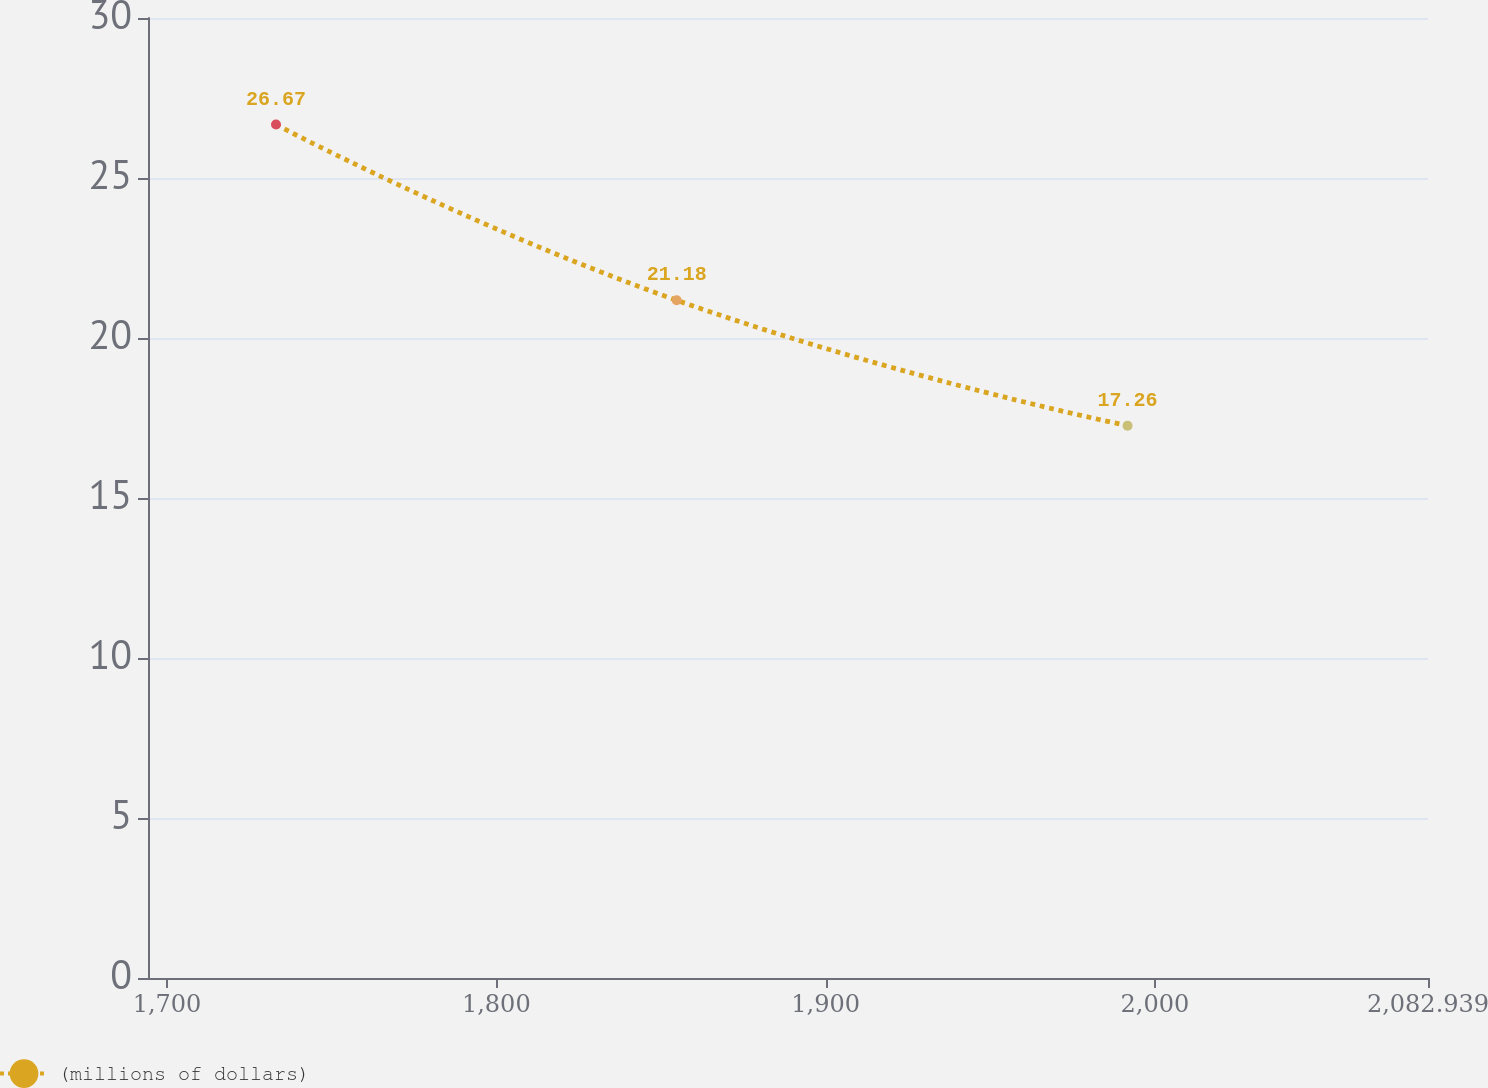Convert chart to OTSL. <chart><loc_0><loc_0><loc_500><loc_500><line_chart><ecel><fcel>(millions of dollars)<nl><fcel>1733.1<fcel>26.67<nl><fcel>1854.77<fcel>21.18<nl><fcel>1991.7<fcel>17.26<nl><fcel>2121.81<fcel>11.19<nl></chart> 